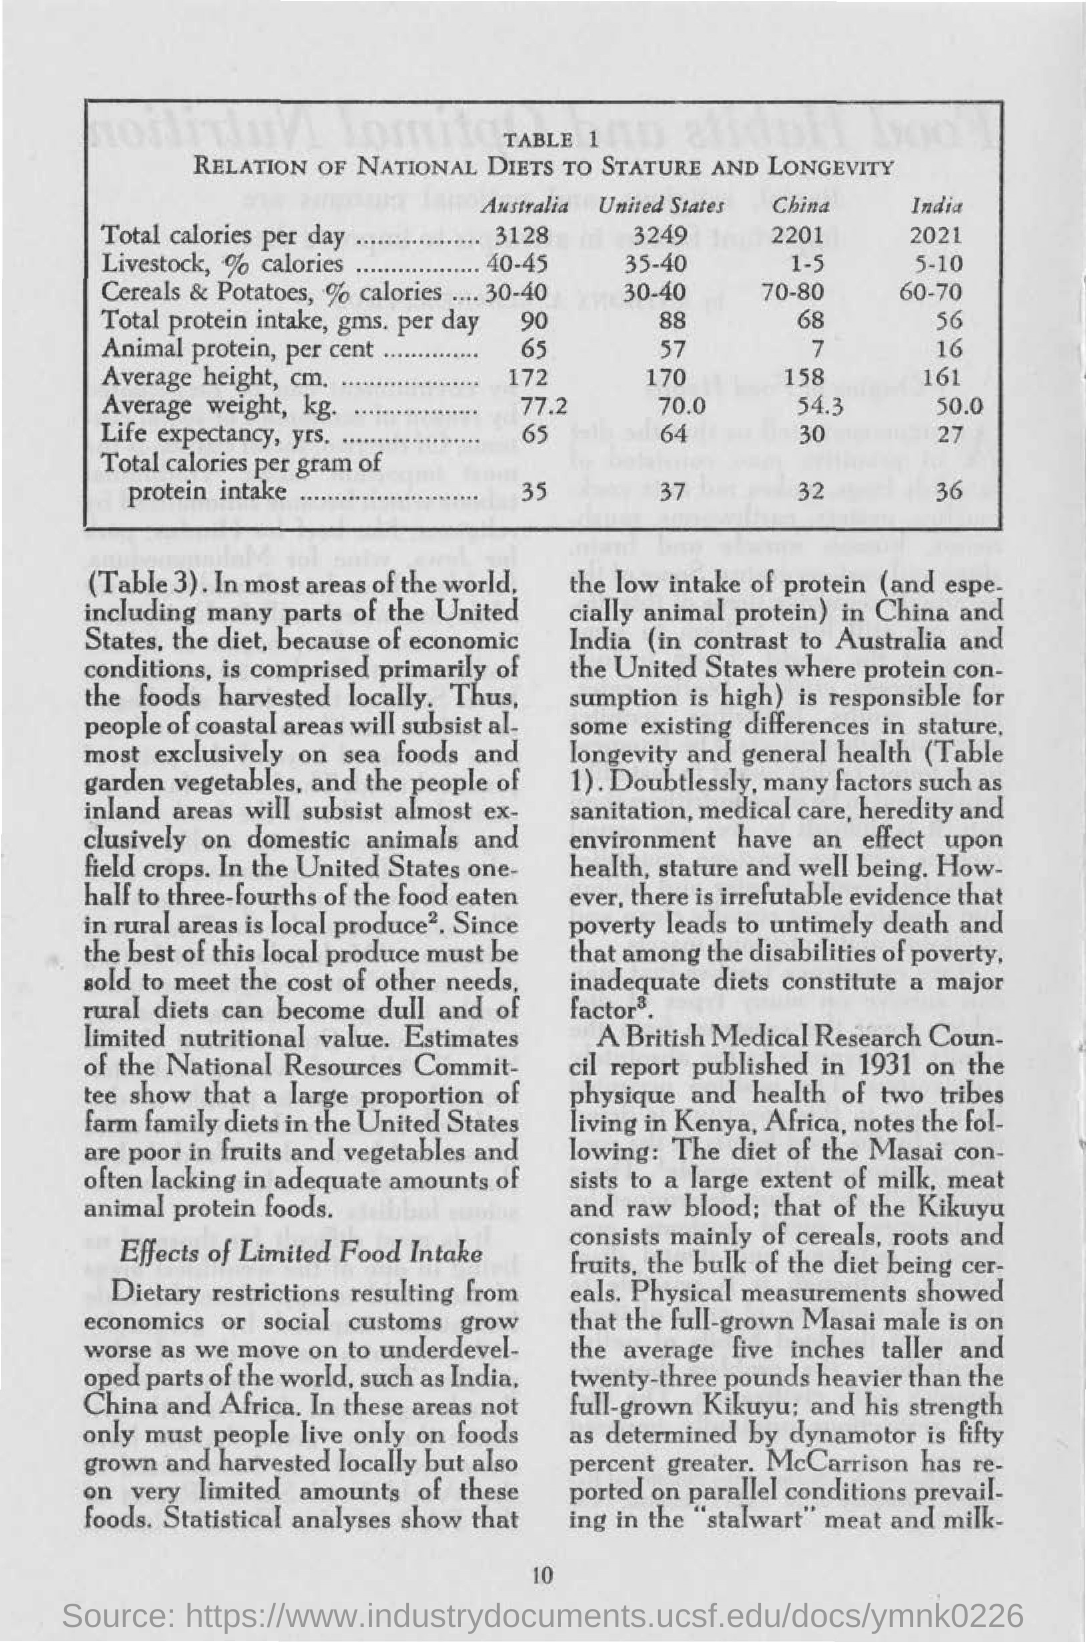Give some essential details in this illustration. The total calories per gram of protein intake for the United States is 37. According to sources, the total calories per gram of protein intake for China is approximately 32. The total caloric intake for India in 2021 is [insert value here]. The total calories per day for Australia is 3128. 